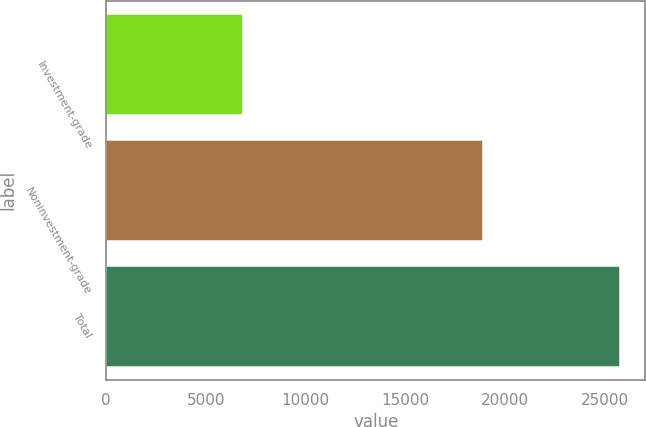Convert chart. <chart><loc_0><loc_0><loc_500><loc_500><bar_chart><fcel>Investment-grade<fcel>Noninvestment-grade<fcel>Total<nl><fcel>6836<fcel>18891<fcel>25727<nl></chart> 